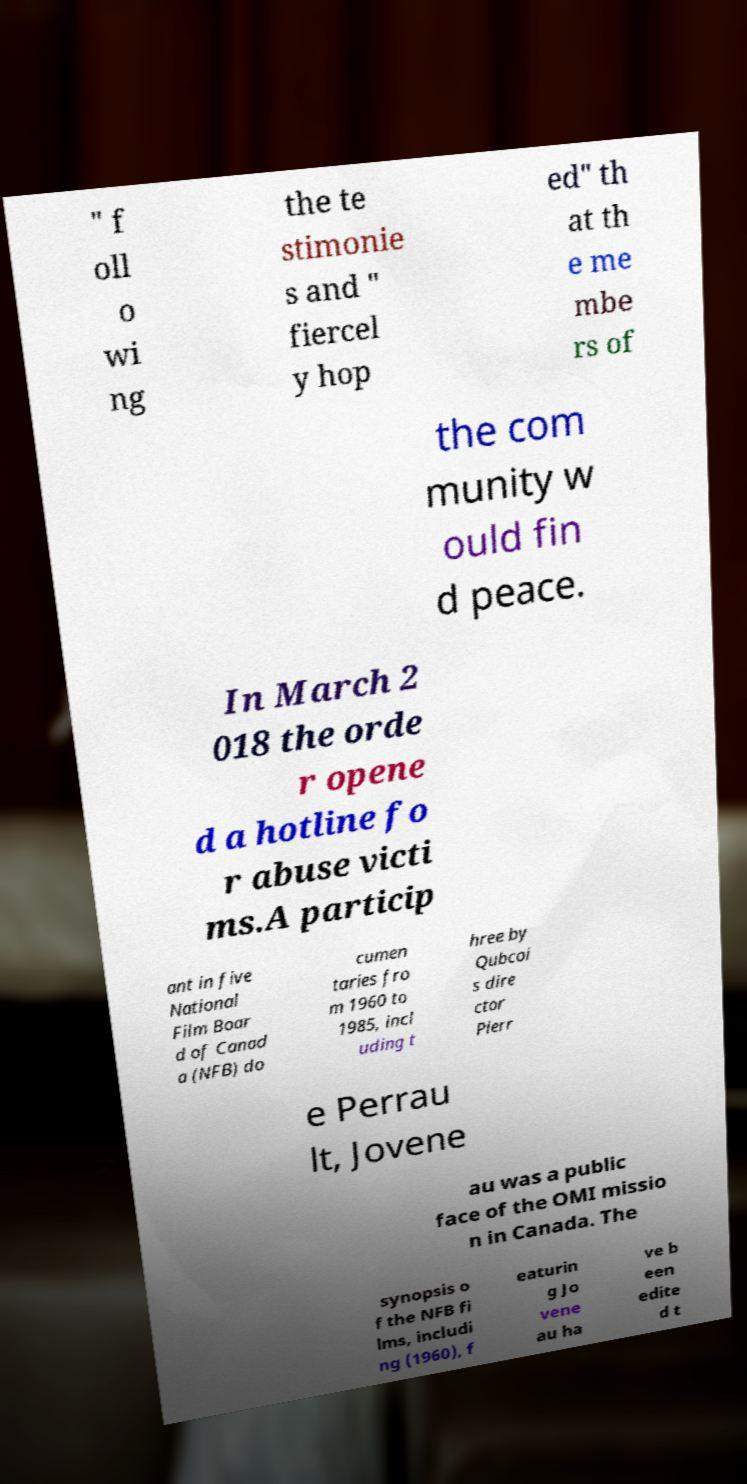Can you read and provide the text displayed in the image?This photo seems to have some interesting text. Can you extract and type it out for me? " f oll o wi ng the te stimonie s and " fiercel y hop ed" th at th e me mbe rs of the com munity w ould fin d peace. In March 2 018 the orde r opene d a hotline fo r abuse victi ms.A particip ant in five National Film Boar d of Canad a (NFB) do cumen taries fro m 1960 to 1985, incl uding t hree by Qubcoi s dire ctor Pierr e Perrau lt, Jovene au was a public face of the OMI missio n in Canada. The synopsis o f the NFB fi lms, includi ng (1960), f eaturin g Jo vene au ha ve b een edite d t 